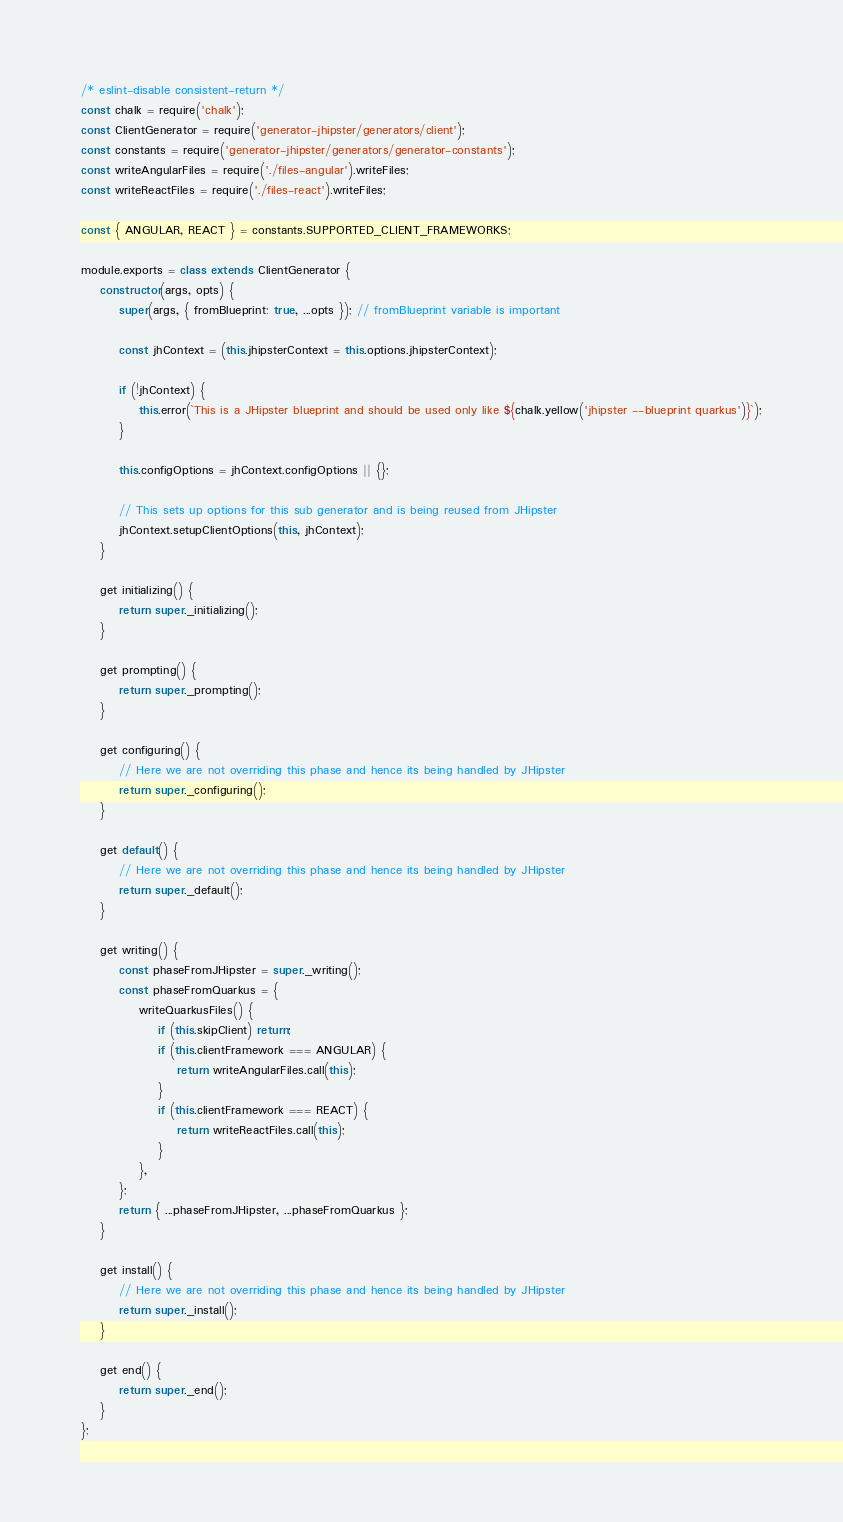Convert code to text. <code><loc_0><loc_0><loc_500><loc_500><_JavaScript_>/* eslint-disable consistent-return */
const chalk = require('chalk');
const ClientGenerator = require('generator-jhipster/generators/client');
const constants = require('generator-jhipster/generators/generator-constants');
const writeAngularFiles = require('./files-angular').writeFiles;
const writeReactFiles = require('./files-react').writeFiles;

const { ANGULAR, REACT } = constants.SUPPORTED_CLIENT_FRAMEWORKS;

module.exports = class extends ClientGenerator {
    constructor(args, opts) {
        super(args, { fromBlueprint: true, ...opts }); // fromBlueprint variable is important

        const jhContext = (this.jhipsterContext = this.options.jhipsterContext);

        if (!jhContext) {
            this.error(`This is a JHipster blueprint and should be used only like ${chalk.yellow('jhipster --blueprint quarkus')}`);
        }

        this.configOptions = jhContext.configOptions || {};

        // This sets up options for this sub generator and is being reused from JHipster
        jhContext.setupClientOptions(this, jhContext);
    }

    get initializing() {
        return super._initializing();
    }

    get prompting() {
        return super._prompting();
    }

    get configuring() {
        // Here we are not overriding this phase and hence its being handled by JHipster
        return super._configuring();
    }

    get default() {
        // Here we are not overriding this phase and hence its being handled by JHipster
        return super._default();
    }

    get writing() {
        const phaseFromJHipster = super._writing();
        const phaseFromQuarkus = {
            writeQuarkusFiles() {
                if (this.skipClient) return;
                if (this.clientFramework === ANGULAR) {
                    return writeAngularFiles.call(this);
                }
                if (this.clientFramework === REACT) {
                    return writeReactFiles.call(this);
                }
            },
        };
        return { ...phaseFromJHipster, ...phaseFromQuarkus };
    }

    get install() {
        // Here we are not overriding this phase and hence its being handled by JHipster
        return super._install();
    }

    get end() {
        return super._end();
    }
};
</code> 